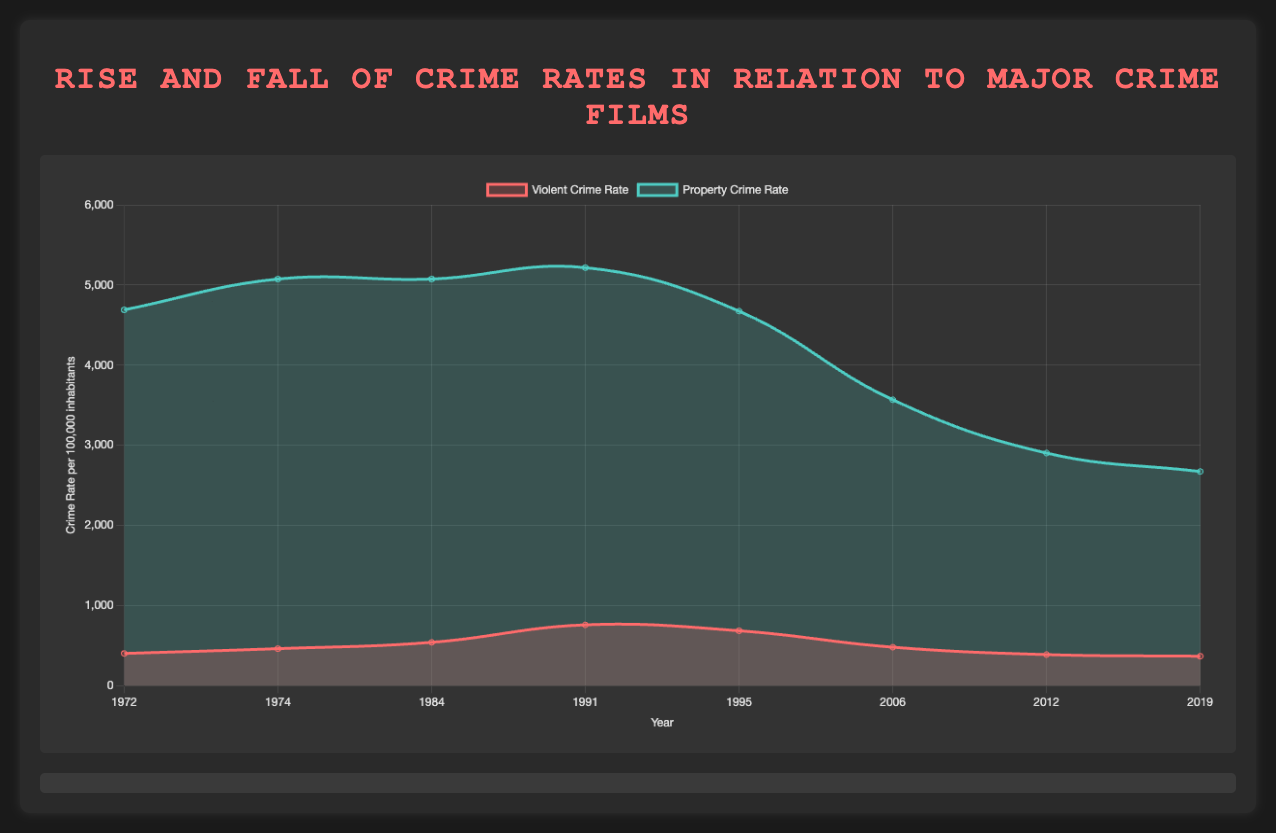What year had the highest violent crime rate, and which film was released that year? Look at the graph and find the peak of the 'Violent Crime Rate' curve. The peak is around 1991. Check the corresponding film released in 1991, which is "Boyz n the Hood".
Answer: 1991, Boyz n the Hood In which year did the violent crime rate decrease significantly from the previous major film release year? Compare the violent crime rates from one point to the next on the 'Violent Crime Rate' curve. The biggest drop is from 1991 (758.2) to 1995 (684.5), associated with the release of "Boyz n the Hood" and "Heat".
Answer: 1995 Which year had the lowest property crime rate and what film was released that year? Check the property crime rate curve and locate the lowest point which is in 2019 with the release of "Joker".
Answer: 2019, Joker How did the violent crime rate change between the release of "Chinatown" and "Beverly Hills Cop"? Identify the violent crime rates in 1974 (461.1 for "Chinatown") and 1984 (539.9 for "Beverly Hills Cop"). Calculate the difference, which is an increase of 78.8.
Answer: It increased by 78.8 Which film release is associated with the smallest difference in property crime rate between two consecutive major film release years? Explore the property crime rate changes between consecutive film release years. The smallest change is between 1974 (5074.2) and 1984 (5074.1), a difference of only 0.1, corresponding to "Chinatown" and "Beverly Hills Cop" release years.
Answer: Chinatown, Beverly Hills Cop When did the property crime rate first drop below 3000 after a film release, and which film was it? Locate the points on the property crime rate curve where it first drops below 3000. This occurs in 2012 with the film "End of Watch".
Answer: 2012, End of Watch Which year witnessed a larger decrease in the violent crime rate, from 1991 to 1995 or from 2006 to 2012? Compare the decreases in violent crime rates between 1991 (758.2) to 1995 (684.5) and from 2006 (479.3) to 2012 (386.9). Calculations show a decrease of 73.7 (1991-1995) and 92.4 (2006-2012). Therefore, the larger decrease is from 2006 to 2012.
Answer: 2006 to 2012 For which film did the property crime rate show the greatest reduction from its previous rate? Compare reductions in property crime rates between each consecutive film release year. The largest reduction is from 5097.1 (Beverly Hills Cop) in 1984 to 4673.2 (Heat) in 1995, a reduction of 506.9.
Answer: Heat What is the average violent crime rate of the years 1984, 1991, and 1995? Add the violent crime rates for 1984 (539.9), 1991 (758.2), and 1995 (684.5). The sum is 1982.6. Divide this by 3 to get the average, which is 660.87.
Answer: 660.87 How did the portrayal of police in "End of Watch" affect the crime rates in comparison to the film "The Departed"? Look at the notes and compare them with corresponding violent and property crime rates: "The Departed" in 2006 (violent: 479.3, property: 3567.2) and "End of Watch" in 2012 (violent: 386.9, property: 2902.4). Both rates decreased significantly from "The Departed" to "End of Watch".
Answer: Both violent and property crime rates decreased after "End of Watch" 